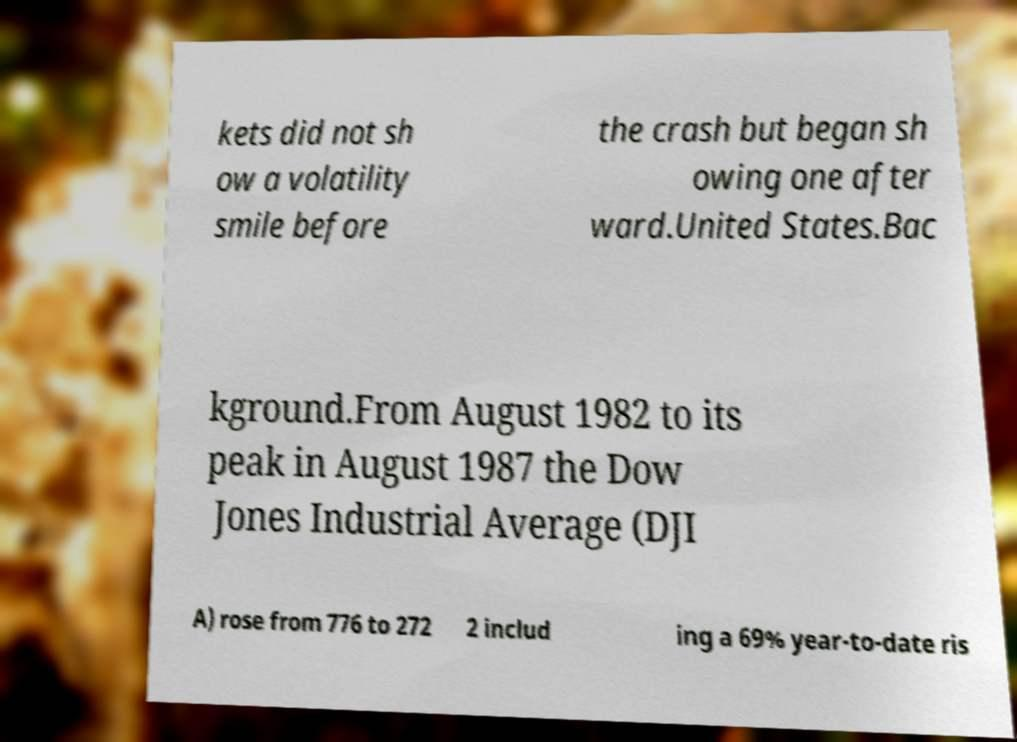What messages or text are displayed in this image? I need them in a readable, typed format. kets did not sh ow a volatility smile before the crash but began sh owing one after ward.United States.Bac kground.From August 1982 to its peak in August 1987 the Dow Jones Industrial Average (DJI A) rose from 776 to 272 2 includ ing a 69% year-to-date ris 